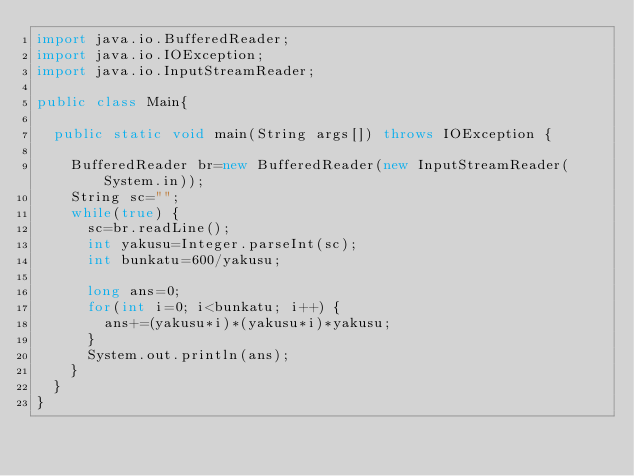<code> <loc_0><loc_0><loc_500><loc_500><_Java_>import java.io.BufferedReader;
import java.io.IOException;
import java.io.InputStreamReader;

public class Main{

	public static void main(String args[]) throws IOException {

		BufferedReader br=new BufferedReader(new InputStreamReader(System.in));
		String sc="";
		while(true) {
			sc=br.readLine();
			int yakusu=Integer.parseInt(sc);
			int bunkatu=600/yakusu;

			long ans=0;
			for(int i=0; i<bunkatu; i++) {
				ans+=(yakusu*i)*(yakusu*i)*yakusu;
			}
			System.out.println(ans);
		}
	}
}
</code> 